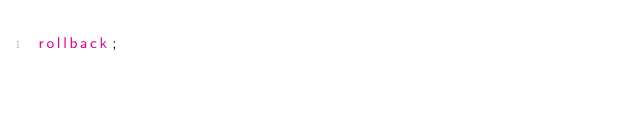Convert code to text. <code><loc_0><loc_0><loc_500><loc_500><_SQL_>rollback;
</code> 